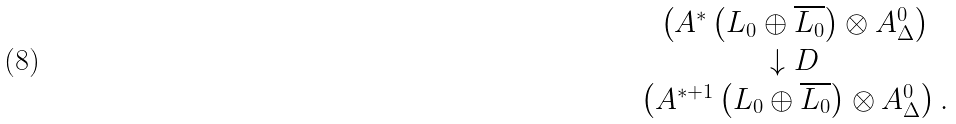Convert formula to latex. <formula><loc_0><loc_0><loc_500><loc_500>\begin{array} { c } \left ( A ^ { * } \left ( L _ { 0 } \oplus \overline { L _ { 0 } } \right ) \otimes A _ { \Delta } ^ { 0 } \right ) \\ \downarrow D \\ \left ( A ^ { * + 1 } \left ( L _ { 0 } \oplus \overline { L _ { 0 } } \right ) \otimes A _ { \Delta } ^ { 0 } \right ) . \end{array}</formula> 